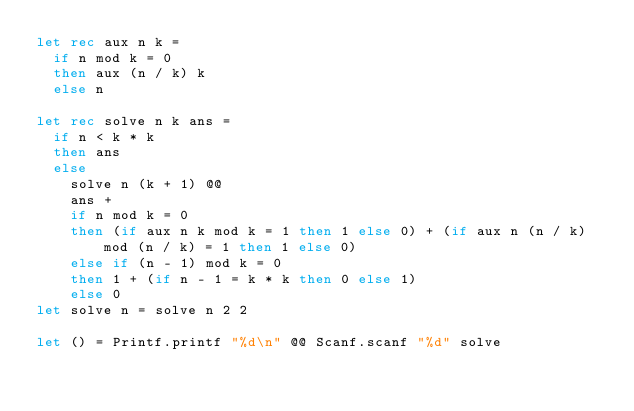<code> <loc_0><loc_0><loc_500><loc_500><_OCaml_>let rec aux n k =
  if n mod k = 0
  then aux (n / k) k
  else n

let rec solve n k ans =
  if n < k * k
  then ans
  else
    solve n (k + 1) @@
    ans +
    if n mod k = 0
    then (if aux n k mod k = 1 then 1 else 0) + (if aux n (n / k) mod (n / k) = 1 then 1 else 0)
    else if (n - 1) mod k = 0
    then 1 + (if n - 1 = k * k then 0 else 1)
    else 0
let solve n = solve n 2 2

let () = Printf.printf "%d\n" @@ Scanf.scanf "%d" solve</code> 